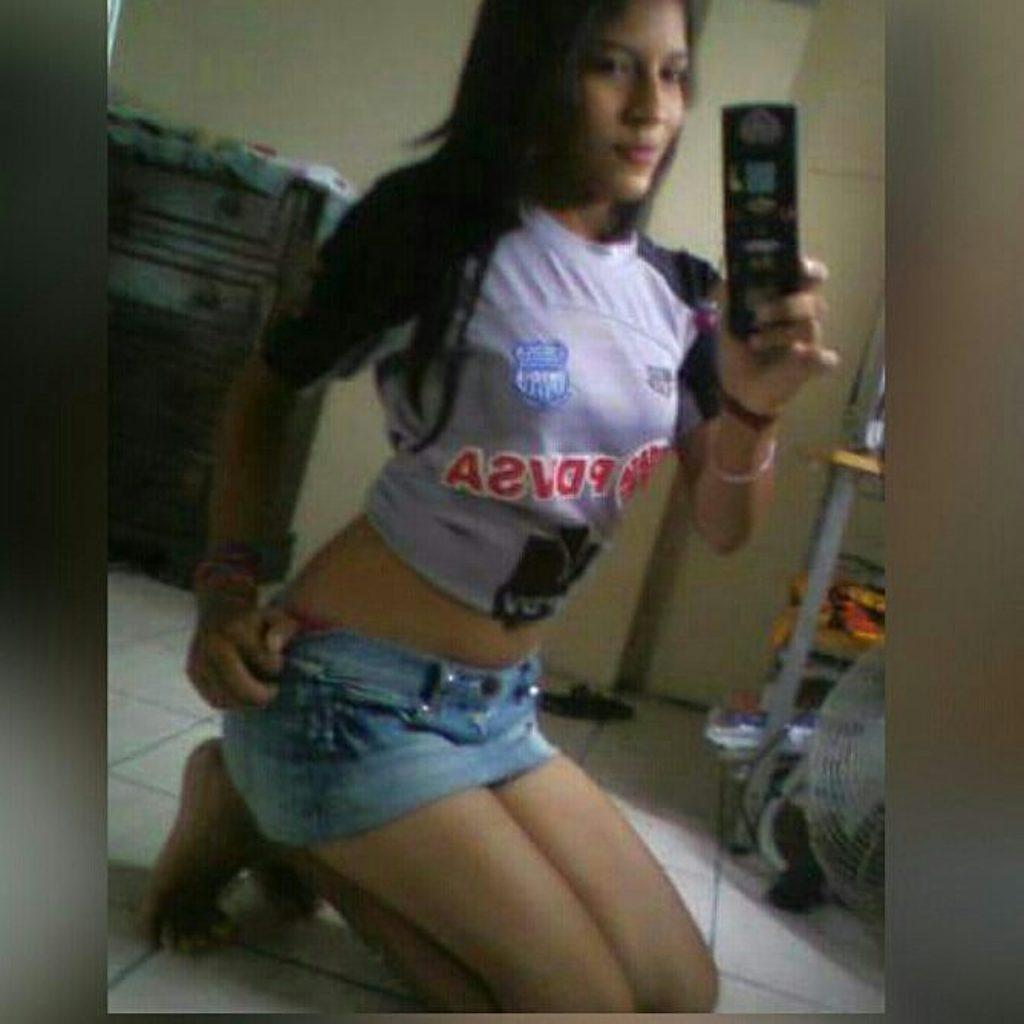What is the person in the image holding? There is a person holding an object in the image. What can be seen in the background of the image? There is a cupboard in the background of the image. What color is the wall in the image? The wall is in cream color. How many matches are on the floor in the image? There are no matches present in the image. What is the temperature of the object the person is holding in the image? The provided facts do not mention the temperature of the object the person is holding, so it cannot be determined from the image. 